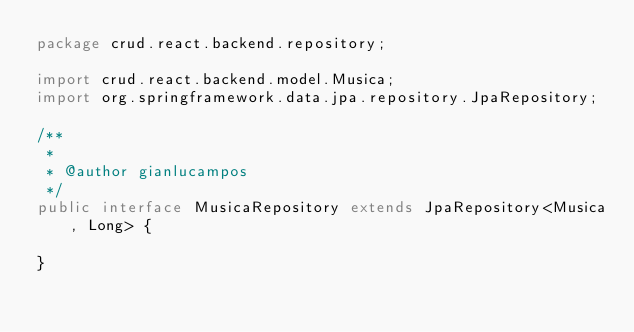Convert code to text. <code><loc_0><loc_0><loc_500><loc_500><_Java_>package crud.react.backend.repository;

import crud.react.backend.model.Musica;
import org.springframework.data.jpa.repository.JpaRepository;

/**
 *
 * @author gianlucampos
 */
public interface MusicaRepository extends JpaRepository<Musica, Long> {

}
</code> 